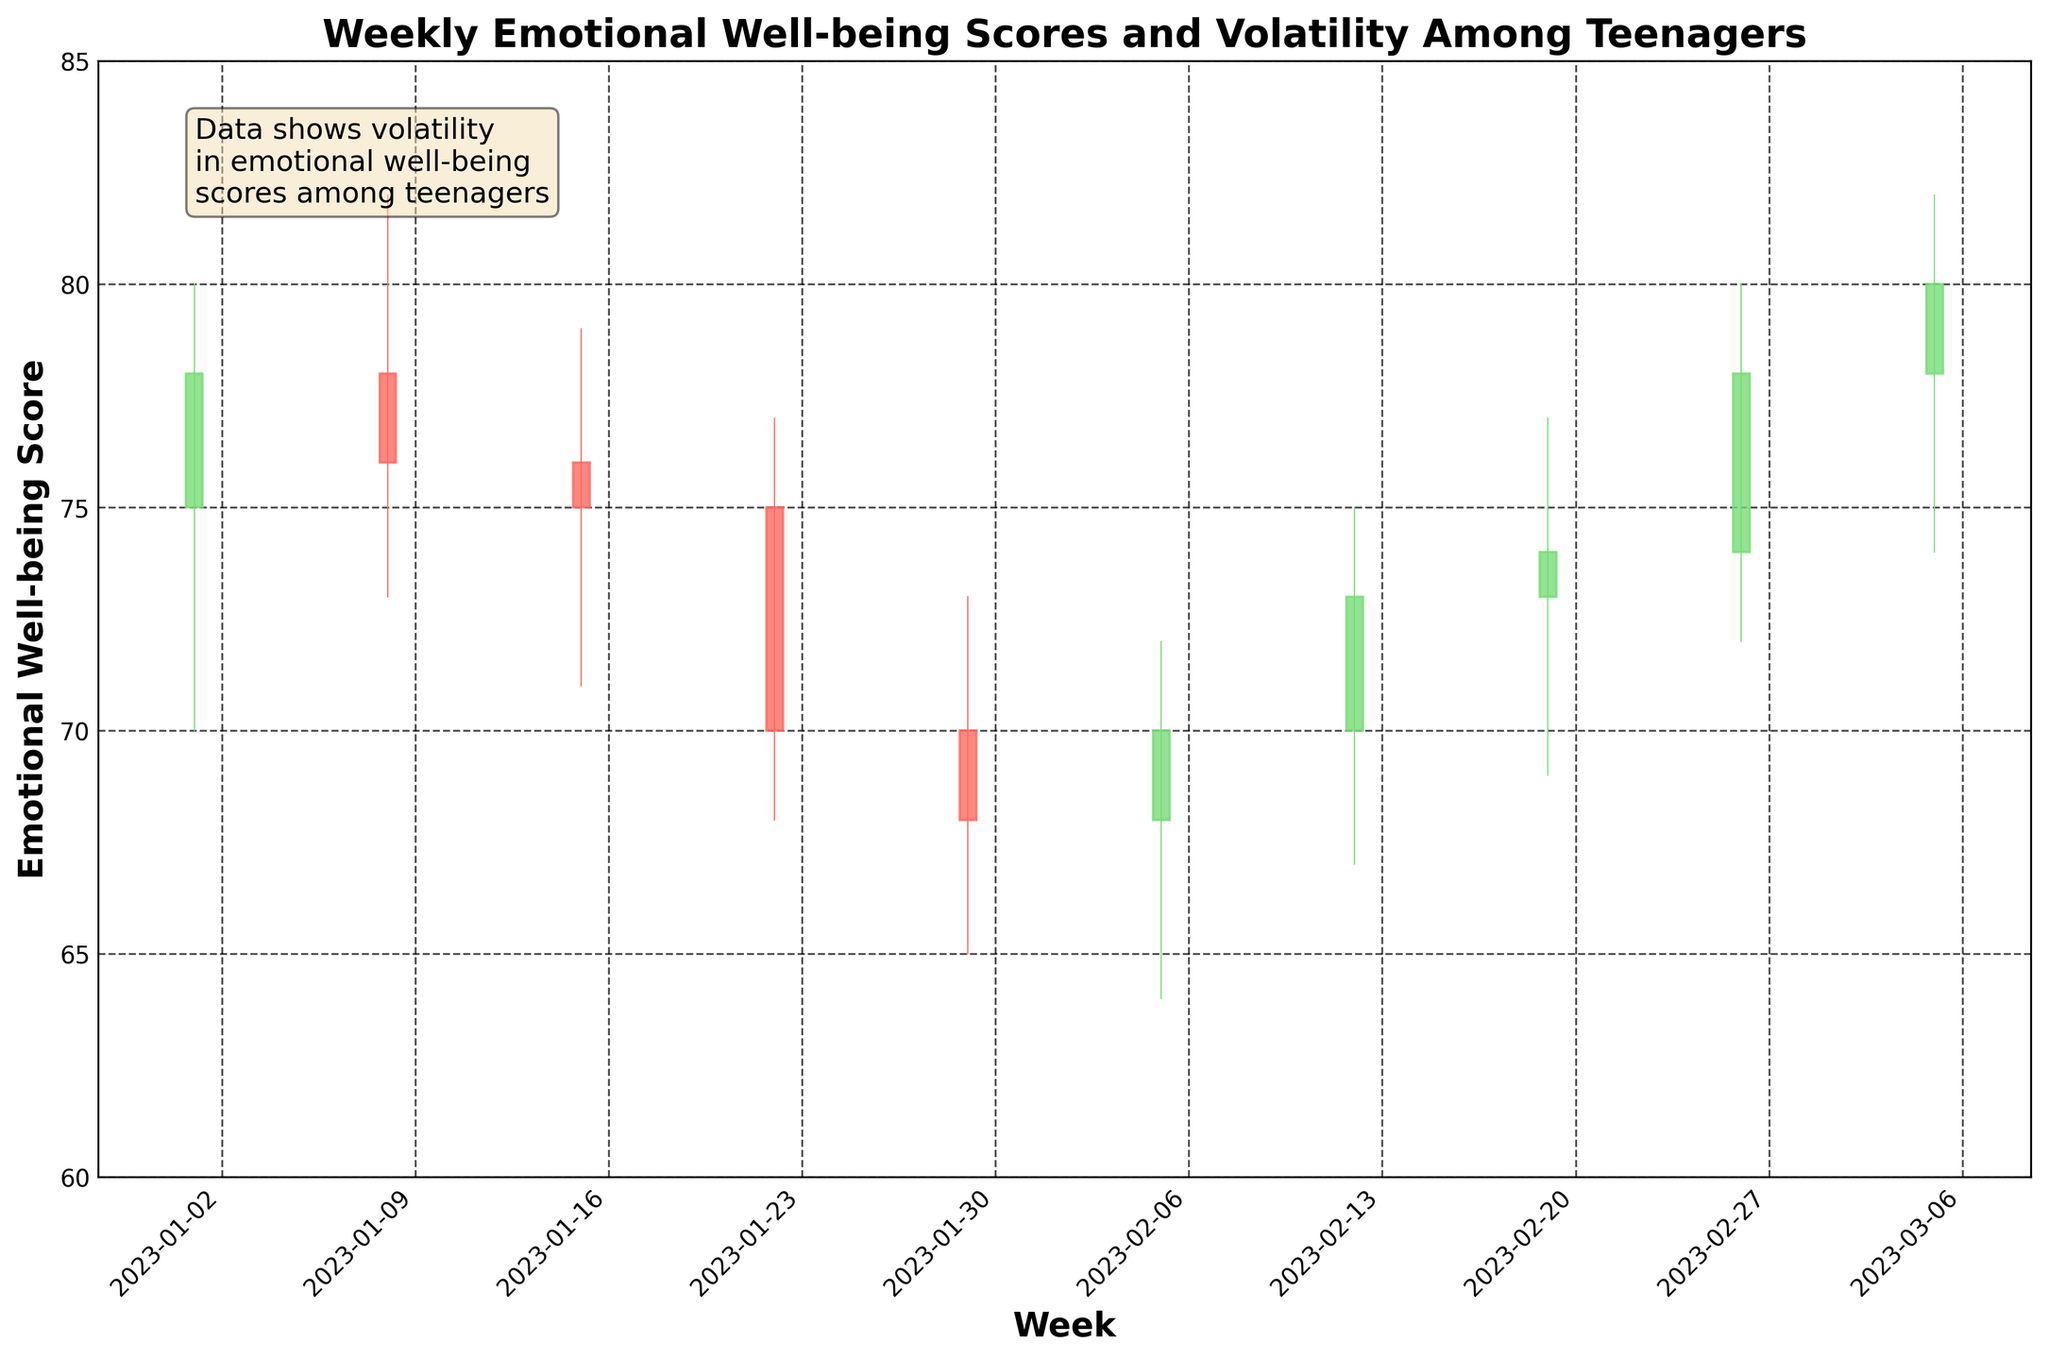What is the title of the figure? The title is usually found at the top of the figure. In this figure, it is placed in a bold font above the plot.
Answer: Weekly Emotional Well-being Scores and Volatility Among Teenagers How many weeks' data are presented in the plot? Each candlestick represents one week. By counting the candlesticks, we can determine the number of weeks.
Answer: 10 weeks What is the lowest emotional well-being score recorded during this period? The lowest score can be identified by looking at the lowest point in the entire candlestick plot, which occurs in the week of 2023-01-29 at a value of 65.
Answer: 65 Which week showed the highest emotional volatility? The emotional volatility for each week is represented by the difference between the high and low values. The week with the biggest difference between these two values is the week of 2023-03-05 with a high of 82 and a low of 74, resulting in a range of 8.
Answer: 2023-03-05 What is the general trend in the well-being scores from January to March? To observe the trend, look at the general direction of the candlesticks' closing values from the beginning to the end of the period. The scores show a decrease from January to early February and then an upward trend towards the end of February and early March.
Answer: Decline, then rise What are the opening and closing scores of the week of 2023-02-12? Referring to the candlestick for the week of 2023-02-12, the scores open at 70 and close at 73.
Answer: Opening: 70, Closing: 73 Which week has the highest closing score, and what is that score? The highest closing score can be identified by looking at the top of the body of each candlestick. The highest close is on the week of 2023-03-05 with a score of 80.
Answer: Week of 2023-03-05, Score: 80 Compare the emotional well-being scores’ high values between the week of 2023-01-29 and the week of 2023-02-26. Which week had a higher score? Checking the high values of each week, the week of 2023-01-29 had a high of 73, and the week of 2023-02-26 had a high of 80. Therefore, the week of 2023-02-26 had a higher score.
Answer: Week of 2023-02-26 What was the trend in the lowest scores from 2023-01-01 to 2023-02-05? Observing the lowest values of each candlestick from the beginning of January to early February shows a generally downward trend: 70, 73, 71, 68, 65, and finally 64.
Answer: Downward 